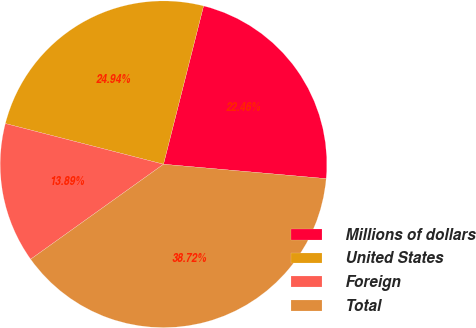Convert chart to OTSL. <chart><loc_0><loc_0><loc_500><loc_500><pie_chart><fcel>Millions of dollars<fcel>United States<fcel>Foreign<fcel>Total<nl><fcel>22.46%<fcel>24.94%<fcel>13.89%<fcel>38.72%<nl></chart> 